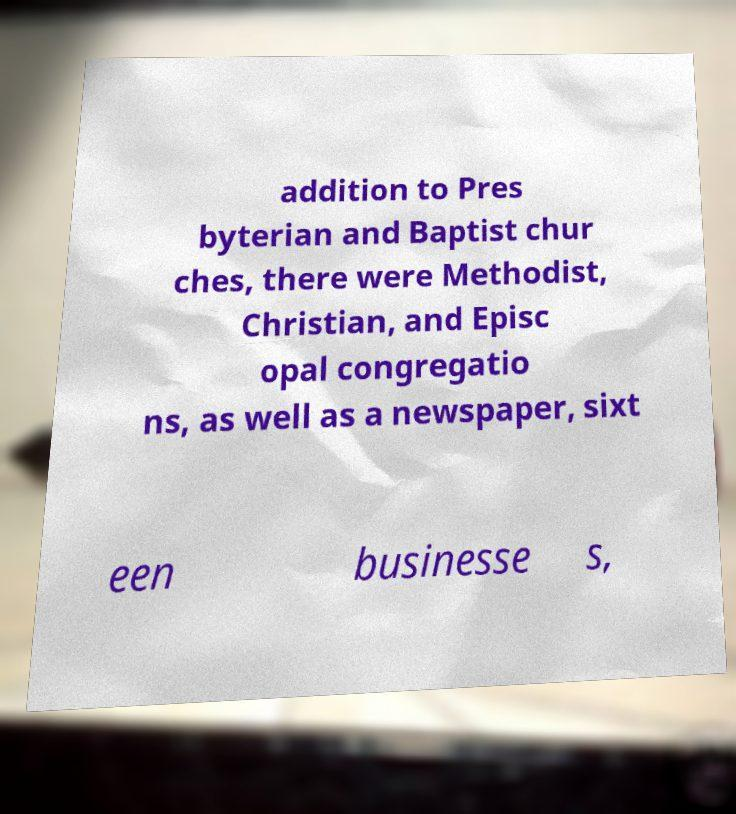Could you assist in decoding the text presented in this image and type it out clearly? addition to Pres byterian and Baptist chur ches, there were Methodist, Christian, and Episc opal congregatio ns, as well as a newspaper, sixt een businesse s, 